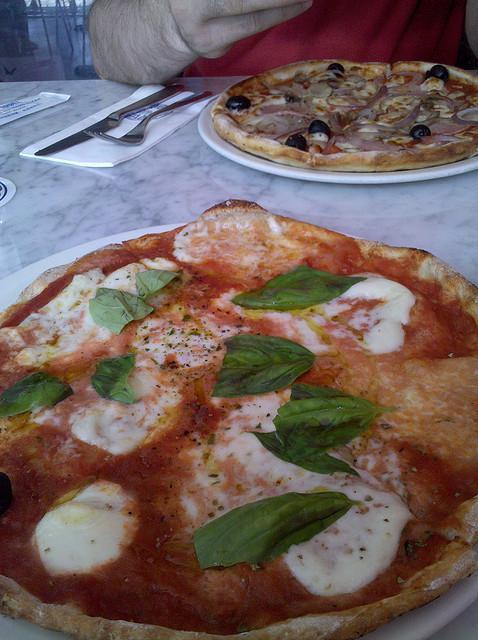How many pizzas are there?
Give a very brief answer. 2. How many people are there?
Give a very brief answer. 1. 